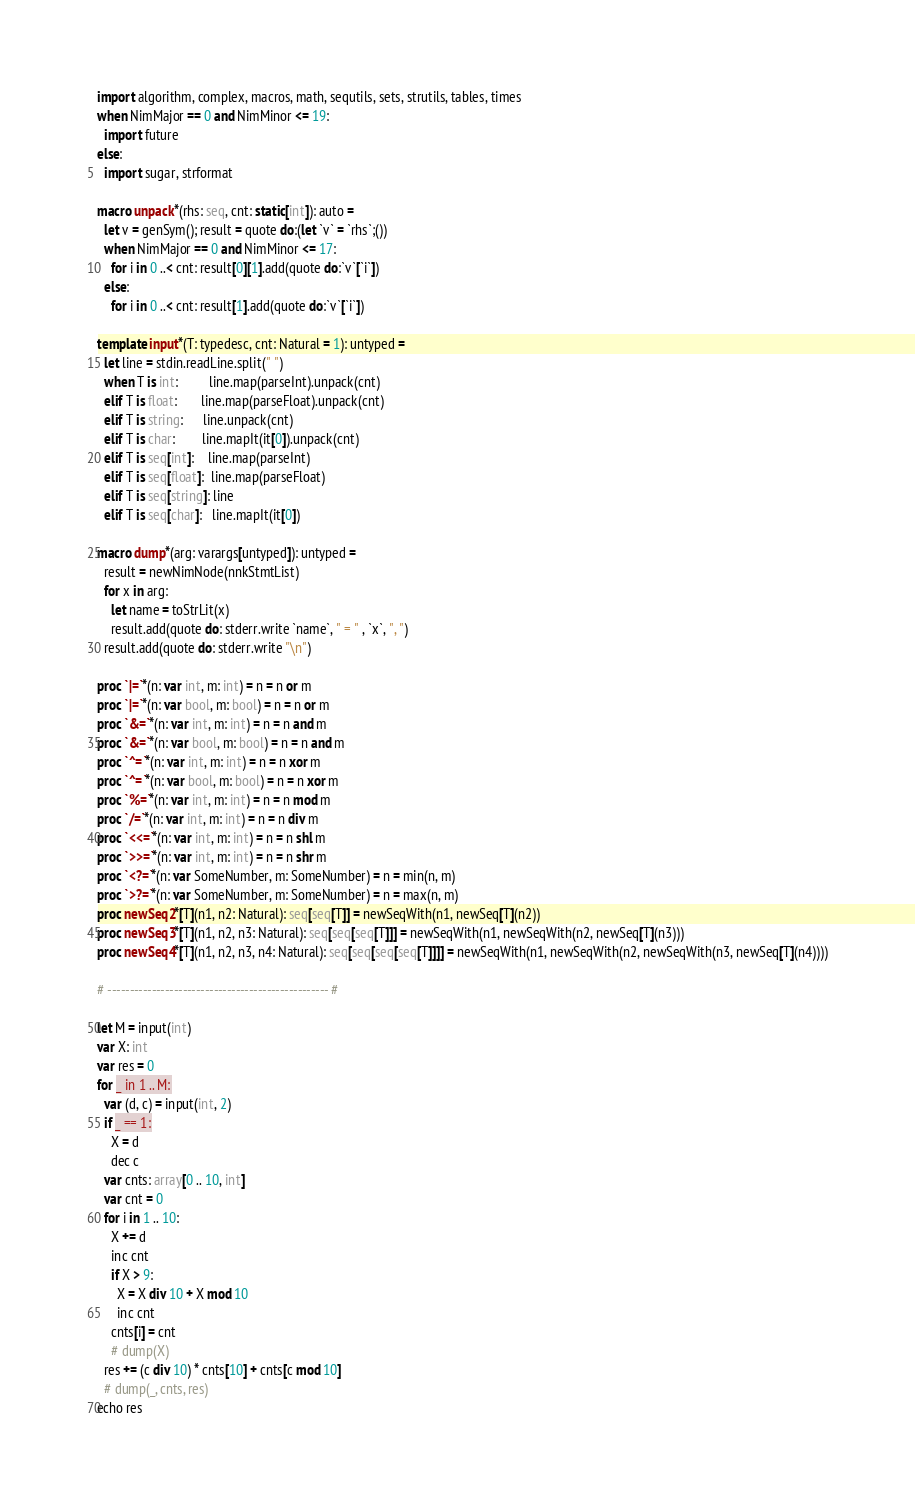<code> <loc_0><loc_0><loc_500><loc_500><_Nim_>import algorithm, complex, macros, math, sequtils, sets, strutils, tables, times
when NimMajor == 0 and NimMinor <= 19:
  import future
else:
  import sugar, strformat

macro unpack*(rhs: seq, cnt: static[int]): auto =
  let v = genSym(); result = quote do:(let `v` = `rhs`;())
  when NimMajor == 0 and NimMinor <= 17:
    for i in 0 ..< cnt: result[0][1].add(quote do:`v`[`i`])
  else:
    for i in 0 ..< cnt: result[1].add(quote do:`v`[`i`])

template input*(T: typedesc, cnt: Natural = 1): untyped =
  let line = stdin.readLine.split(" ")
  when T is int:         line.map(parseInt).unpack(cnt)
  elif T is float:       line.map(parseFloat).unpack(cnt)
  elif T is string:      line.unpack(cnt)
  elif T is char:        line.mapIt(it[0]).unpack(cnt)
  elif T is seq[int]:    line.map(parseInt)
  elif T is seq[float]:  line.map(parseFloat)
  elif T is seq[string]: line
  elif T is seq[char]:   line.mapIt(it[0])

macro dump*(arg: varargs[untyped]): untyped =
  result = newNimNode(nnkStmtList)
  for x in arg:
    let name = toStrLit(x)
    result.add(quote do: stderr.write `name`, " = " , `x`, ", ")
  result.add(quote do: stderr.write "\n")

proc `|=`*(n: var int, m: int) = n = n or m
proc `|=`*(n: var bool, m: bool) = n = n or m
proc `&=`*(n: var int, m: int) = n = n and m
proc `&=`*(n: var bool, m: bool) = n = n and m
proc `^=`*(n: var int, m: int) = n = n xor m
proc `^=`*(n: var bool, m: bool) = n = n xor m
proc `%=`*(n: var int, m: int) = n = n mod m
proc `/=`*(n: var int, m: int) = n = n div m
proc `<<=`*(n: var int, m: int) = n = n shl m
proc `>>=`*(n: var int, m: int) = n = n shr m
proc `<?=`*(n: var SomeNumber, m: SomeNumber) = n = min(n, m)
proc `>?=`*(n: var SomeNumber, m: SomeNumber) = n = max(n, m)
proc newSeq2*[T](n1, n2: Natural): seq[seq[T]] = newSeqWith(n1, newSeq[T](n2))
proc newSeq3*[T](n1, n2, n3: Natural): seq[seq[seq[T]]] = newSeqWith(n1, newSeqWith(n2, newSeq[T](n3)))
proc newSeq4*[T](n1, n2, n3, n4: Natural): seq[seq[seq[seq[T]]]] = newSeqWith(n1, newSeqWith(n2, newSeqWith(n3, newSeq[T](n4))))

# -------------------------------------------------- #

let M = input(int)
var X: int
var res = 0
for _ in 1 .. M:
  var (d, c) = input(int, 2)
  if _ == 1:
    X = d
    dec c
  var cnts: array[0 .. 10, int]
  var cnt = 0
  for i in 1 .. 10:
    X += d
    inc cnt
    if X > 9:
      X = X div 10 + X mod 10
      inc cnt
    cnts[i] = cnt
    # dump(X)
  res += (c div 10) * cnts[10] + cnts[c mod 10]
  # dump(_, cnts, res)
echo res</code> 